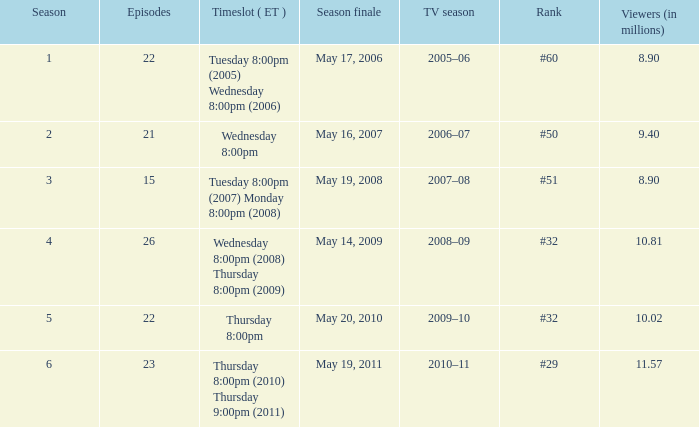How many seasons was the rank equal to #50? 1.0. 